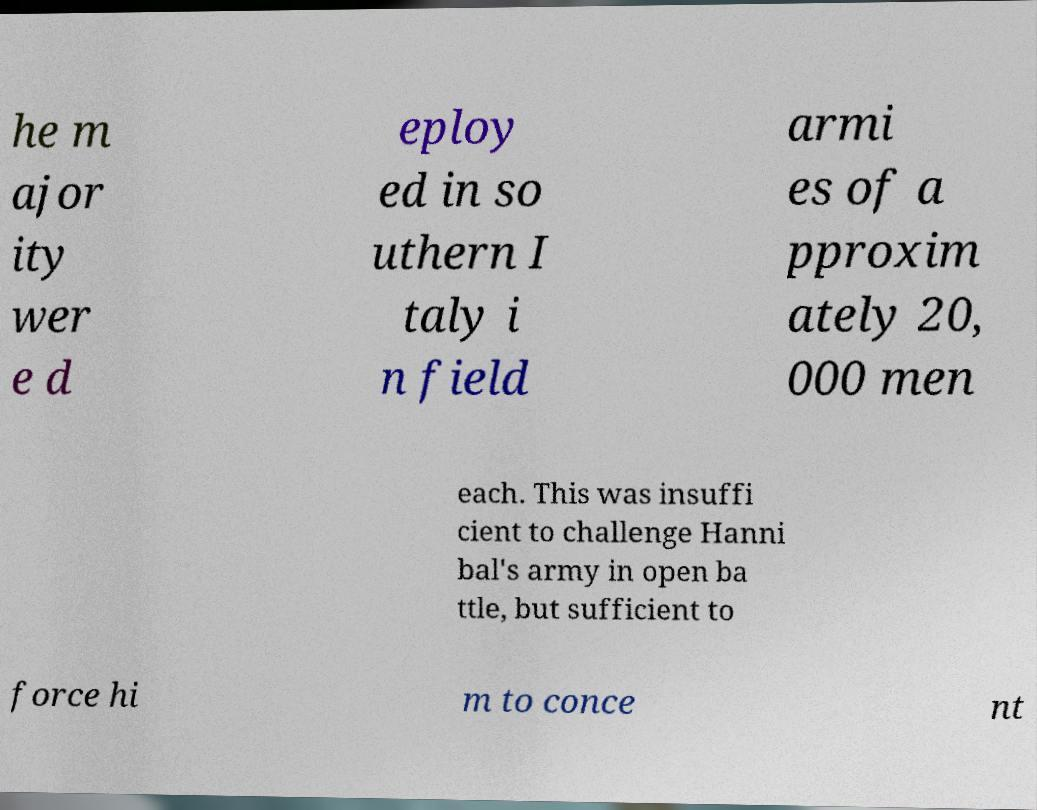Could you extract and type out the text from this image? he m ajor ity wer e d eploy ed in so uthern I taly i n field armi es of a pproxim ately 20, 000 men each. This was insuffi cient to challenge Hanni bal's army in open ba ttle, but sufficient to force hi m to conce nt 